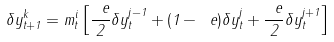<formula> <loc_0><loc_0><loc_500><loc_500>\delta y _ { t + 1 } ^ { k } = m _ { t } ^ { i } \left [ \frac { \ e } { 2 } \delta y _ { t } ^ { j - 1 } + ( 1 - \ e ) \delta y _ { t } ^ { j } + \frac { \ e } { 2 } \delta y _ { t } ^ { j + 1 } \right ]</formula> 